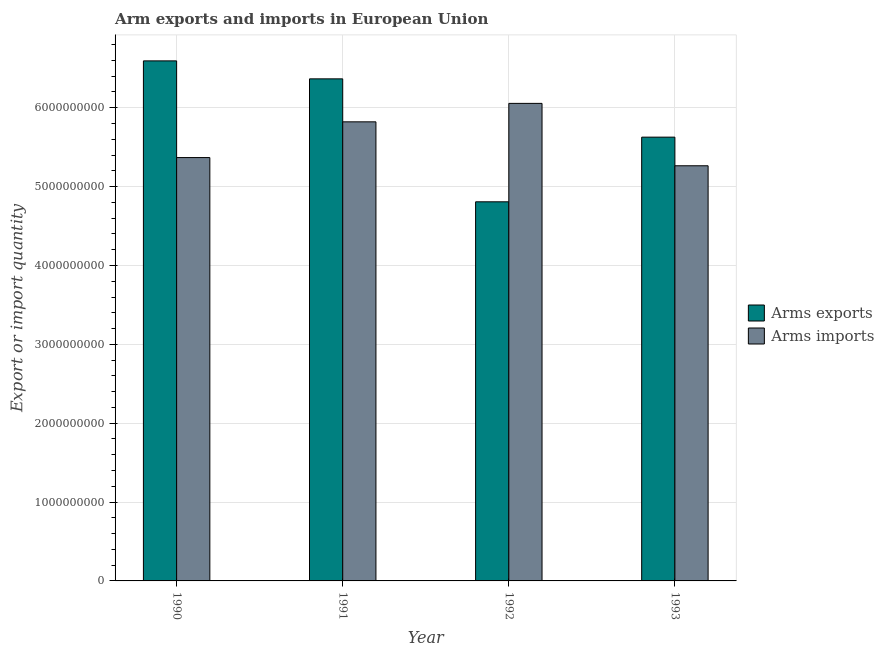How many bars are there on the 3rd tick from the right?
Your answer should be compact. 2. In how many cases, is the number of bars for a given year not equal to the number of legend labels?
Your answer should be very brief. 0. What is the arms imports in 1993?
Provide a succinct answer. 5.26e+09. Across all years, what is the maximum arms exports?
Offer a very short reply. 6.59e+09. Across all years, what is the minimum arms exports?
Give a very brief answer. 4.81e+09. What is the total arms exports in the graph?
Give a very brief answer. 2.34e+1. What is the difference between the arms imports in 1990 and that in 1993?
Offer a very short reply. 1.04e+08. What is the difference between the arms exports in 1990 and the arms imports in 1993?
Your response must be concise. 9.67e+08. What is the average arms imports per year?
Your answer should be compact. 5.63e+09. In the year 1991, what is the difference between the arms exports and arms imports?
Your answer should be very brief. 0. What is the ratio of the arms exports in 1991 to that in 1992?
Provide a succinct answer. 1.32. Is the arms exports in 1991 less than that in 1993?
Your answer should be very brief. No. Is the difference between the arms imports in 1992 and 1993 greater than the difference between the arms exports in 1992 and 1993?
Offer a very short reply. No. What is the difference between the highest and the second highest arms imports?
Your answer should be compact. 2.34e+08. What is the difference between the highest and the lowest arms exports?
Offer a terse response. 1.79e+09. In how many years, is the arms imports greater than the average arms imports taken over all years?
Keep it short and to the point. 2. Is the sum of the arms exports in 1992 and 1993 greater than the maximum arms imports across all years?
Offer a very short reply. Yes. What does the 1st bar from the left in 1992 represents?
Give a very brief answer. Arms exports. What does the 1st bar from the right in 1992 represents?
Provide a short and direct response. Arms imports. How many bars are there?
Provide a succinct answer. 8. Does the graph contain grids?
Ensure brevity in your answer.  Yes. Where does the legend appear in the graph?
Provide a short and direct response. Center right. How many legend labels are there?
Provide a short and direct response. 2. What is the title of the graph?
Give a very brief answer. Arm exports and imports in European Union. What is the label or title of the X-axis?
Keep it short and to the point. Year. What is the label or title of the Y-axis?
Ensure brevity in your answer.  Export or import quantity. What is the Export or import quantity of Arms exports in 1990?
Your answer should be very brief. 6.59e+09. What is the Export or import quantity in Arms imports in 1990?
Offer a terse response. 5.37e+09. What is the Export or import quantity of Arms exports in 1991?
Provide a short and direct response. 6.37e+09. What is the Export or import quantity in Arms imports in 1991?
Keep it short and to the point. 5.82e+09. What is the Export or import quantity in Arms exports in 1992?
Give a very brief answer. 4.81e+09. What is the Export or import quantity of Arms imports in 1992?
Your answer should be very brief. 6.06e+09. What is the Export or import quantity of Arms exports in 1993?
Offer a terse response. 5.63e+09. What is the Export or import quantity of Arms imports in 1993?
Provide a succinct answer. 5.26e+09. Across all years, what is the maximum Export or import quantity in Arms exports?
Give a very brief answer. 6.59e+09. Across all years, what is the maximum Export or import quantity in Arms imports?
Your answer should be compact. 6.06e+09. Across all years, what is the minimum Export or import quantity in Arms exports?
Give a very brief answer. 4.81e+09. Across all years, what is the minimum Export or import quantity in Arms imports?
Your answer should be compact. 5.26e+09. What is the total Export or import quantity in Arms exports in the graph?
Your response must be concise. 2.34e+1. What is the total Export or import quantity of Arms imports in the graph?
Give a very brief answer. 2.25e+1. What is the difference between the Export or import quantity of Arms exports in 1990 and that in 1991?
Your answer should be very brief. 2.28e+08. What is the difference between the Export or import quantity of Arms imports in 1990 and that in 1991?
Ensure brevity in your answer.  -4.53e+08. What is the difference between the Export or import quantity of Arms exports in 1990 and that in 1992?
Offer a terse response. 1.79e+09. What is the difference between the Export or import quantity of Arms imports in 1990 and that in 1992?
Give a very brief answer. -6.87e+08. What is the difference between the Export or import quantity of Arms exports in 1990 and that in 1993?
Offer a very short reply. 9.67e+08. What is the difference between the Export or import quantity in Arms imports in 1990 and that in 1993?
Give a very brief answer. 1.04e+08. What is the difference between the Export or import quantity in Arms exports in 1991 and that in 1992?
Your answer should be compact. 1.56e+09. What is the difference between the Export or import quantity in Arms imports in 1991 and that in 1992?
Offer a terse response. -2.34e+08. What is the difference between the Export or import quantity of Arms exports in 1991 and that in 1993?
Keep it short and to the point. 7.39e+08. What is the difference between the Export or import quantity of Arms imports in 1991 and that in 1993?
Your answer should be very brief. 5.57e+08. What is the difference between the Export or import quantity of Arms exports in 1992 and that in 1993?
Provide a short and direct response. -8.20e+08. What is the difference between the Export or import quantity in Arms imports in 1992 and that in 1993?
Give a very brief answer. 7.91e+08. What is the difference between the Export or import quantity of Arms exports in 1990 and the Export or import quantity of Arms imports in 1991?
Ensure brevity in your answer.  7.73e+08. What is the difference between the Export or import quantity in Arms exports in 1990 and the Export or import quantity in Arms imports in 1992?
Make the answer very short. 5.39e+08. What is the difference between the Export or import quantity in Arms exports in 1990 and the Export or import quantity in Arms imports in 1993?
Make the answer very short. 1.33e+09. What is the difference between the Export or import quantity in Arms exports in 1991 and the Export or import quantity in Arms imports in 1992?
Offer a very short reply. 3.11e+08. What is the difference between the Export or import quantity in Arms exports in 1991 and the Export or import quantity in Arms imports in 1993?
Offer a very short reply. 1.10e+09. What is the difference between the Export or import quantity in Arms exports in 1992 and the Export or import quantity in Arms imports in 1993?
Offer a terse response. -4.57e+08. What is the average Export or import quantity of Arms exports per year?
Keep it short and to the point. 5.85e+09. What is the average Export or import quantity of Arms imports per year?
Keep it short and to the point. 5.63e+09. In the year 1990, what is the difference between the Export or import quantity of Arms exports and Export or import quantity of Arms imports?
Your answer should be compact. 1.23e+09. In the year 1991, what is the difference between the Export or import quantity in Arms exports and Export or import quantity in Arms imports?
Provide a short and direct response. 5.45e+08. In the year 1992, what is the difference between the Export or import quantity in Arms exports and Export or import quantity in Arms imports?
Your response must be concise. -1.25e+09. In the year 1993, what is the difference between the Export or import quantity of Arms exports and Export or import quantity of Arms imports?
Provide a short and direct response. 3.63e+08. What is the ratio of the Export or import quantity in Arms exports in 1990 to that in 1991?
Give a very brief answer. 1.04. What is the ratio of the Export or import quantity of Arms imports in 1990 to that in 1991?
Ensure brevity in your answer.  0.92. What is the ratio of the Export or import quantity of Arms exports in 1990 to that in 1992?
Ensure brevity in your answer.  1.37. What is the ratio of the Export or import quantity of Arms imports in 1990 to that in 1992?
Offer a very short reply. 0.89. What is the ratio of the Export or import quantity in Arms exports in 1990 to that in 1993?
Offer a terse response. 1.17. What is the ratio of the Export or import quantity in Arms imports in 1990 to that in 1993?
Give a very brief answer. 1.02. What is the ratio of the Export or import quantity of Arms exports in 1991 to that in 1992?
Keep it short and to the point. 1.32. What is the ratio of the Export or import quantity in Arms imports in 1991 to that in 1992?
Your answer should be compact. 0.96. What is the ratio of the Export or import quantity of Arms exports in 1991 to that in 1993?
Give a very brief answer. 1.13. What is the ratio of the Export or import quantity in Arms imports in 1991 to that in 1993?
Give a very brief answer. 1.11. What is the ratio of the Export or import quantity of Arms exports in 1992 to that in 1993?
Your answer should be compact. 0.85. What is the ratio of the Export or import quantity in Arms imports in 1992 to that in 1993?
Make the answer very short. 1.15. What is the difference between the highest and the second highest Export or import quantity in Arms exports?
Your answer should be compact. 2.28e+08. What is the difference between the highest and the second highest Export or import quantity in Arms imports?
Your answer should be very brief. 2.34e+08. What is the difference between the highest and the lowest Export or import quantity in Arms exports?
Your answer should be very brief. 1.79e+09. What is the difference between the highest and the lowest Export or import quantity in Arms imports?
Make the answer very short. 7.91e+08. 